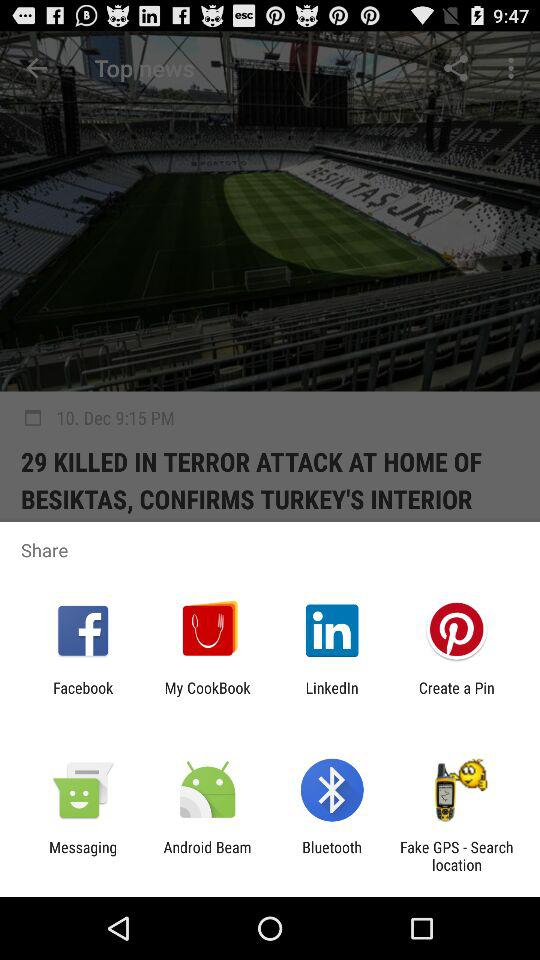Which applications can be used to share? The applications that can be used to share are "Facebook", "My CookBook", "LinkedIn", "Create a Pin", "Messaging", "Android Beam", "Bluetooth" and "Fake GPS - Search location". 